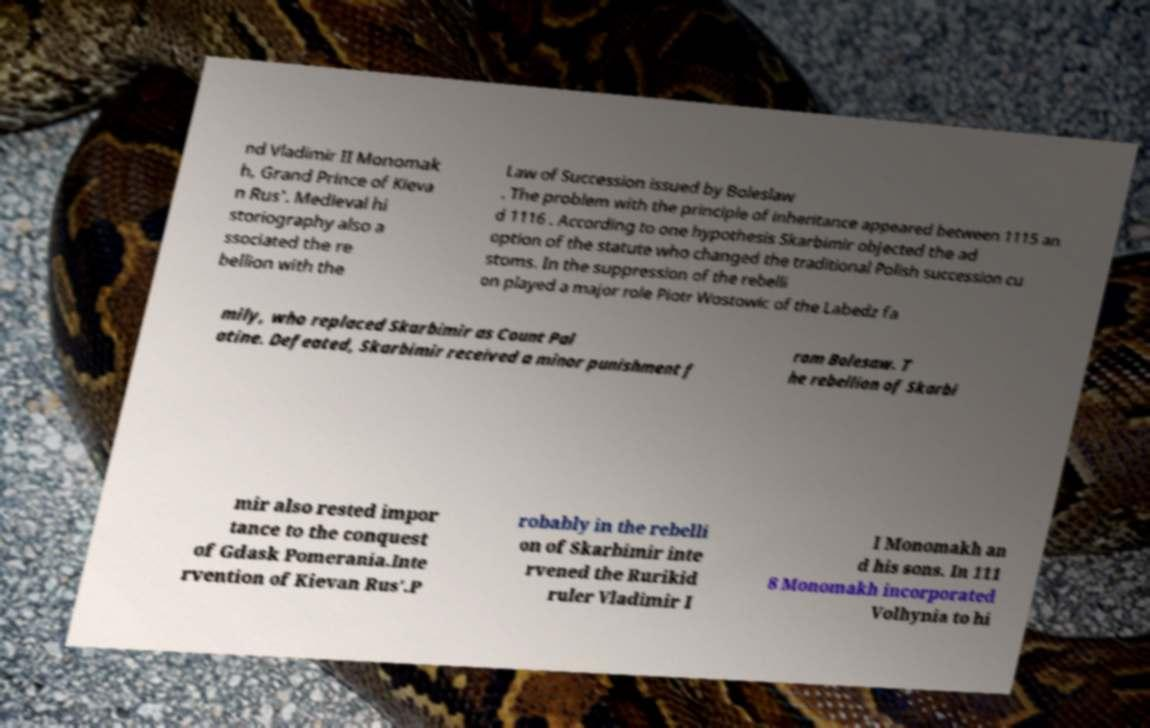For documentation purposes, I need the text within this image transcribed. Could you provide that? nd Vladimir II Monomak h, Grand Prince of Kieva n Rus'. Medieval hi storiography also a ssociated the re bellion with the Law of Succession issued by Boleslaw . The problem with the principle of inheritance appeared between 1115 an d 1116 . According to one hypothesis Skarbimir objected the ad option of the statute who changed the traditional Polish succession cu stoms. In the suppression of the rebelli on played a major role Piotr Wostowic of the Labedz fa mily, who replaced Skarbimir as Count Pal atine. Defeated, Skarbimir received a minor punishment f rom Bolesaw. T he rebellion of Skarbi mir also rested impor tance to the conquest of Gdask Pomerania.Inte rvention of Kievan Rus'.P robably in the rebelli on of Skarbimir inte rvened the Rurikid ruler Vladimir I I Monomakh an d his sons. In 111 8 Monomakh incorporated Volhynia to hi 